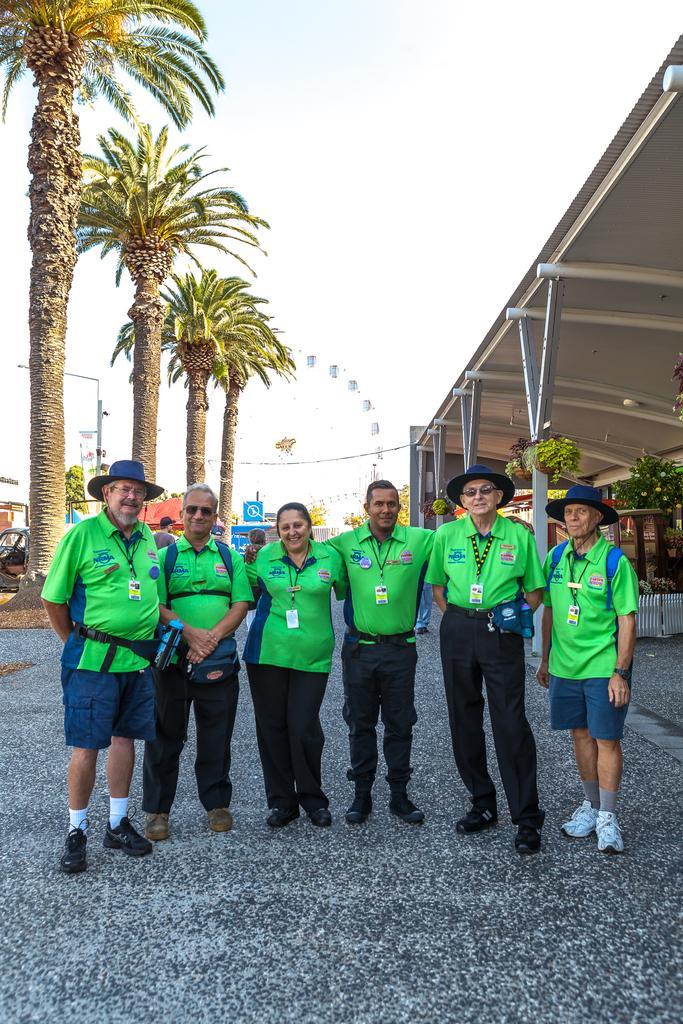Please provide a concise description of this image. In the picture I can see a group of people are standing on the ground. These people are wearing green color T-shirts. In the background I can see trees, a wire, poles, buildings, fence and some other objects. 